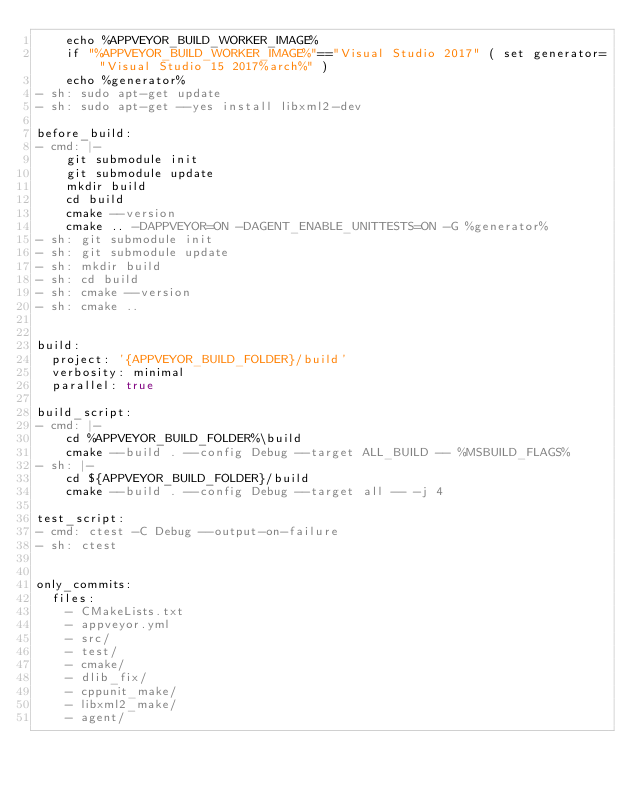Convert code to text. <code><loc_0><loc_0><loc_500><loc_500><_YAML_>    echo %APPVEYOR_BUILD_WORKER_IMAGE%
    if "%APPVEYOR_BUILD_WORKER_IMAGE%"=="Visual Studio 2017" ( set generator="Visual Studio 15 2017%arch%" )
    echo %generator%
- sh: sudo apt-get update
- sh: sudo apt-get --yes install libxml2-dev

before_build:
- cmd: |-
    git submodule init
    git submodule update
    mkdir build
    cd build
    cmake --version
    cmake .. -DAPPVEYOR=ON -DAGENT_ENABLE_UNITTESTS=ON -G %generator%
- sh: git submodule init
- sh: git submodule update
- sh: mkdir build
- sh: cd build
- sh: cmake --version
- sh: cmake ..
    

build:
  project: '{APPVEYOR_BUILD_FOLDER}/build'
  verbosity: minimal
  parallel: true

build_script:
- cmd: |-
    cd %APPVEYOR_BUILD_FOLDER%\build
    cmake --build . --config Debug --target ALL_BUILD -- %MSBUILD_FLAGS%
- sh: |-
    cd ${APPVEYOR_BUILD_FOLDER}/build
    cmake --build . --config Debug --target all -- -j 4

test_script:
- cmd: ctest -C Debug --output-on-failure
- sh: ctest

  
only_commits:
  files:
    - CMakeLists.txt
    - appveyor.yml
    - src/
    - test/
    - cmake/
    - dlib_fix/
    - cppunit_make/
    - libxml2_make/
    - agent/
</code> 